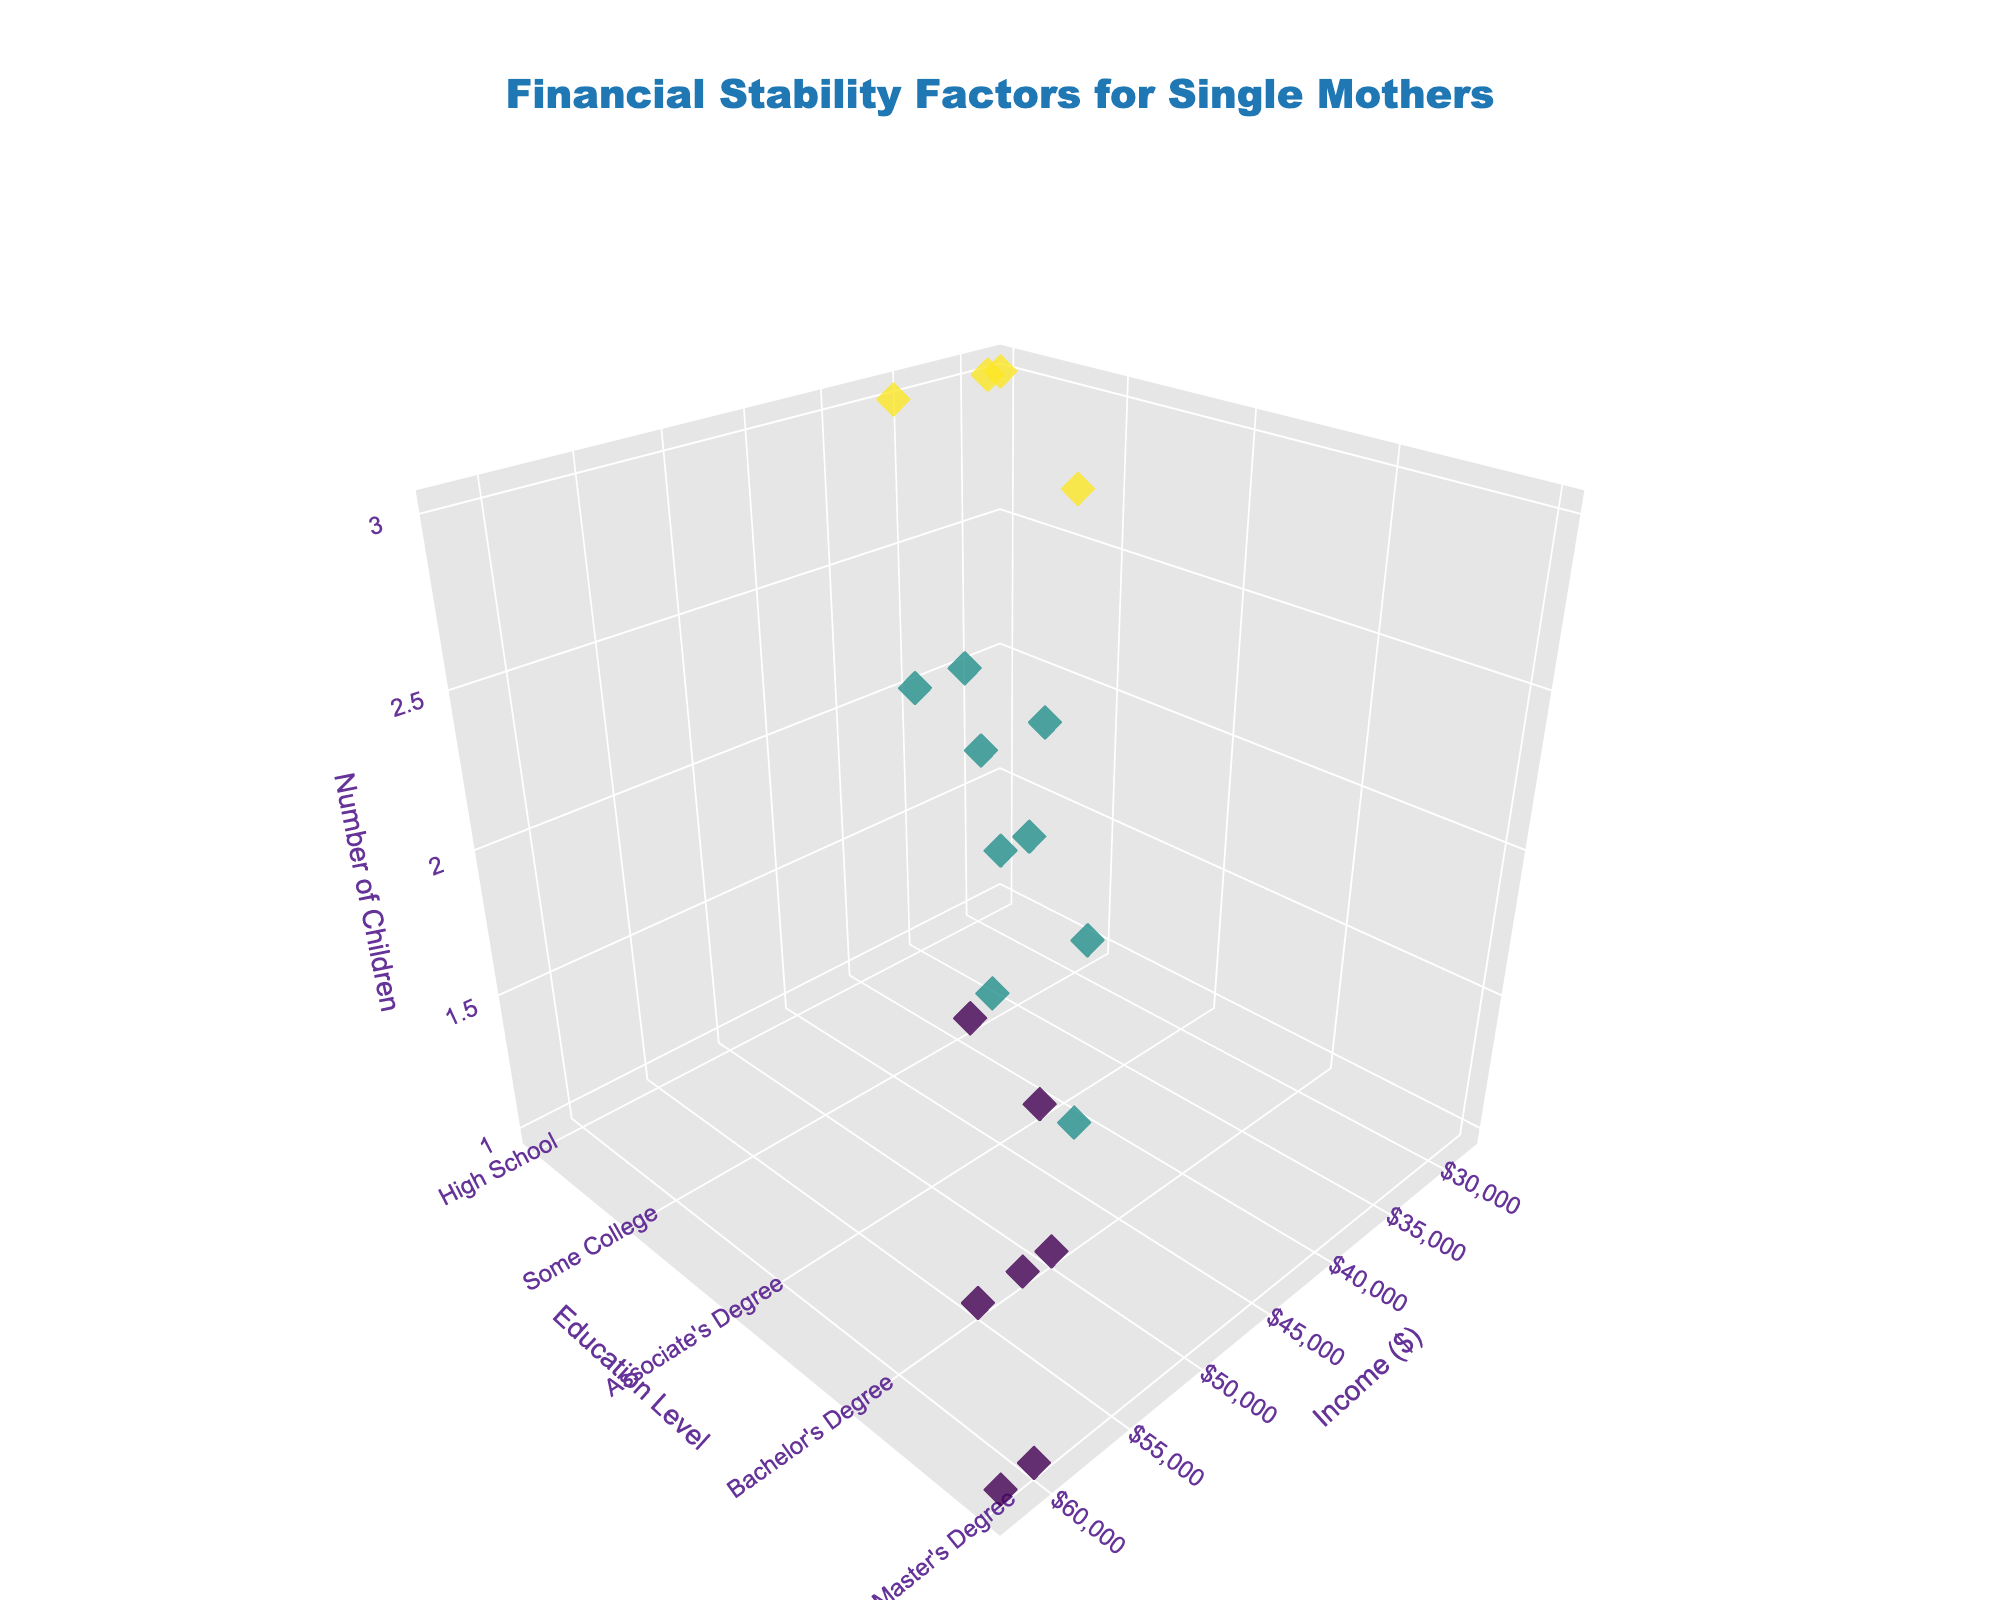what does the figure's title tell us? The title of the figure, "Financial Stability Factors for Single Mothers", indicates that the plot visualizes factors related to financial stability specifically for single mothers. These factors include income, education level, and the number of children.
Answer: Financial stability factors for single mothers How many data points represent single mothers with a Bachelor's Degree education? By checking the y-axis labeled "Education Level" and counting markers along the Bachelor’s Degree category, you can see there are 6 data points.
Answer: 6 Which income level had the highest number of children? Looking at the z-axis representing the number of children, the highest values of 3 correspond to income levels such as $28,000, $36,000, and $40,000.
Answer: 28,000, 36,000, and 40,000 What is the relationship between income and education level? Generally, the plot shows that as the education level increases, the income tends to be higher. This can be observed by noting that higher education levels like Master’s Degree and Bachelor’s Degree are associated with higher income levels on the x-axis.
Answer: Higher education correlates with higher income What are the income, education level, and number of children for the data point in the top right corner of the plot? By scrutinizing the highest and farthest data point in the 3D scatter plot, it can be noted that the income is $62,000, the education level is Master’s Degree and the number of children is 1 as per the text annotations.
Answer: 62,000, Master's Degree, 1 Which education level has the most children overall? Comparing the points on the z-axis for each education level, "High School" has many points at higher values for the number of children (close to 3).
Answer: High School What is the average income for single mothers with an Associate's Degree? Adding the incomes for Associate's Degree ($42,000, $40,000, $45,000, $43,000) and dividing by the number of data points (4): ($42,000 + $40,000 + $45,000 + $43,000) / 4 = $42,500.
Answer: $42,500 Is there a pattern between the number of children and income level for single mothers with a Master’s Degree? Observing the plot, most single mothers with a Master’s Degree have 1 or 2 children and tend to have higher incomes between $58,000 and $62,000.
Answer: Higher incomes with 1-2 children Are there any single mothers with 3 children and a Master's Degree in the data? Looking at the z-axis where the number of children is 3 and cross-referencing with education levels, there are no data points for Master’s Degree at this number.
Answer: No Between a Bachelor’s Degree and an Associate's Degree, which education level reports a higher ranged income distribution? Observing the x-axis points for both education levels, Bachelor’s Degree ranges from $48,000 to $55,000, with some even at $60,000; whereas Associate’s Degree averages lower between $40,000 to $45,000.
Answer: Bachelor's Degree 